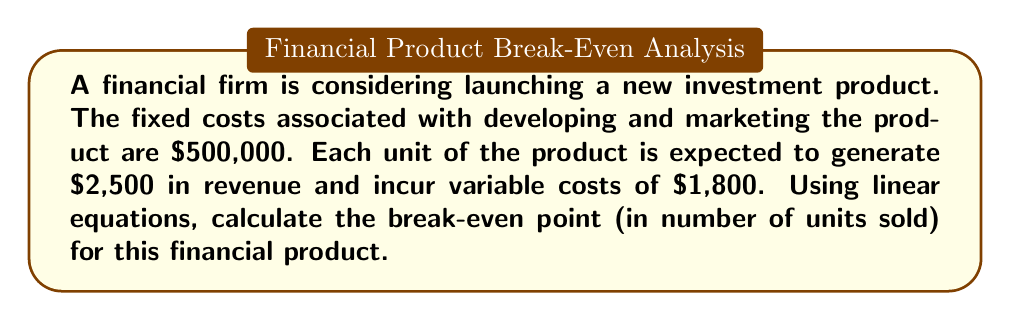Teach me how to tackle this problem. To solve this problem, we'll use the break-even analysis formula:

1) Let $x$ be the number of units sold.

2) Total Revenue (TR) equation:
   $$ TR = 2500x $$

3) Total Cost (TC) equation:
   $$ TC = 500000 + 1800x $$

4) At break-even point, TR = TC:
   $$ 2500x = 500000 + 1800x $$

5) Solve for x:
   $$ 2500x - 1800x = 500000 $$
   $$ 700x = 500000 $$
   $$ x = \frac{500000}{700} = 714.29 $$

6) Since we can't sell a fraction of a unit, we round up to the nearest whole number.

Therefore, the firm needs to sell 715 units of the financial product to break even.
Answer: 715 units 